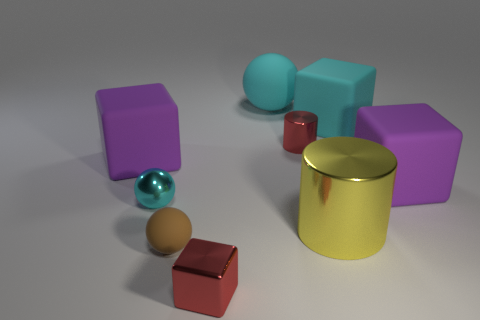Are there any other small spheres that have the same color as the small metal sphere?
Ensure brevity in your answer.  No. Is there a tiny red block?
Your answer should be compact. Yes. Is the cyan metallic thing the same shape as the big yellow metallic object?
Offer a terse response. No. What number of big things are cyan cylinders or red shiny cubes?
Provide a succinct answer. 0. What color is the large shiny object?
Provide a succinct answer. Yellow. The big purple object to the left of the metal object that is to the right of the tiny cylinder is what shape?
Your answer should be very brief. Cube. Are there any tiny brown objects that have the same material as the yellow object?
Offer a terse response. No. There is a cyan object that is on the left side of the brown object; is its size the same as the big cyan ball?
Your response must be concise. No. What number of purple objects are either large rubber spheres or matte things?
Offer a very short reply. 2. What is the big cyan object on the right side of the yellow thing made of?
Offer a terse response. Rubber. 